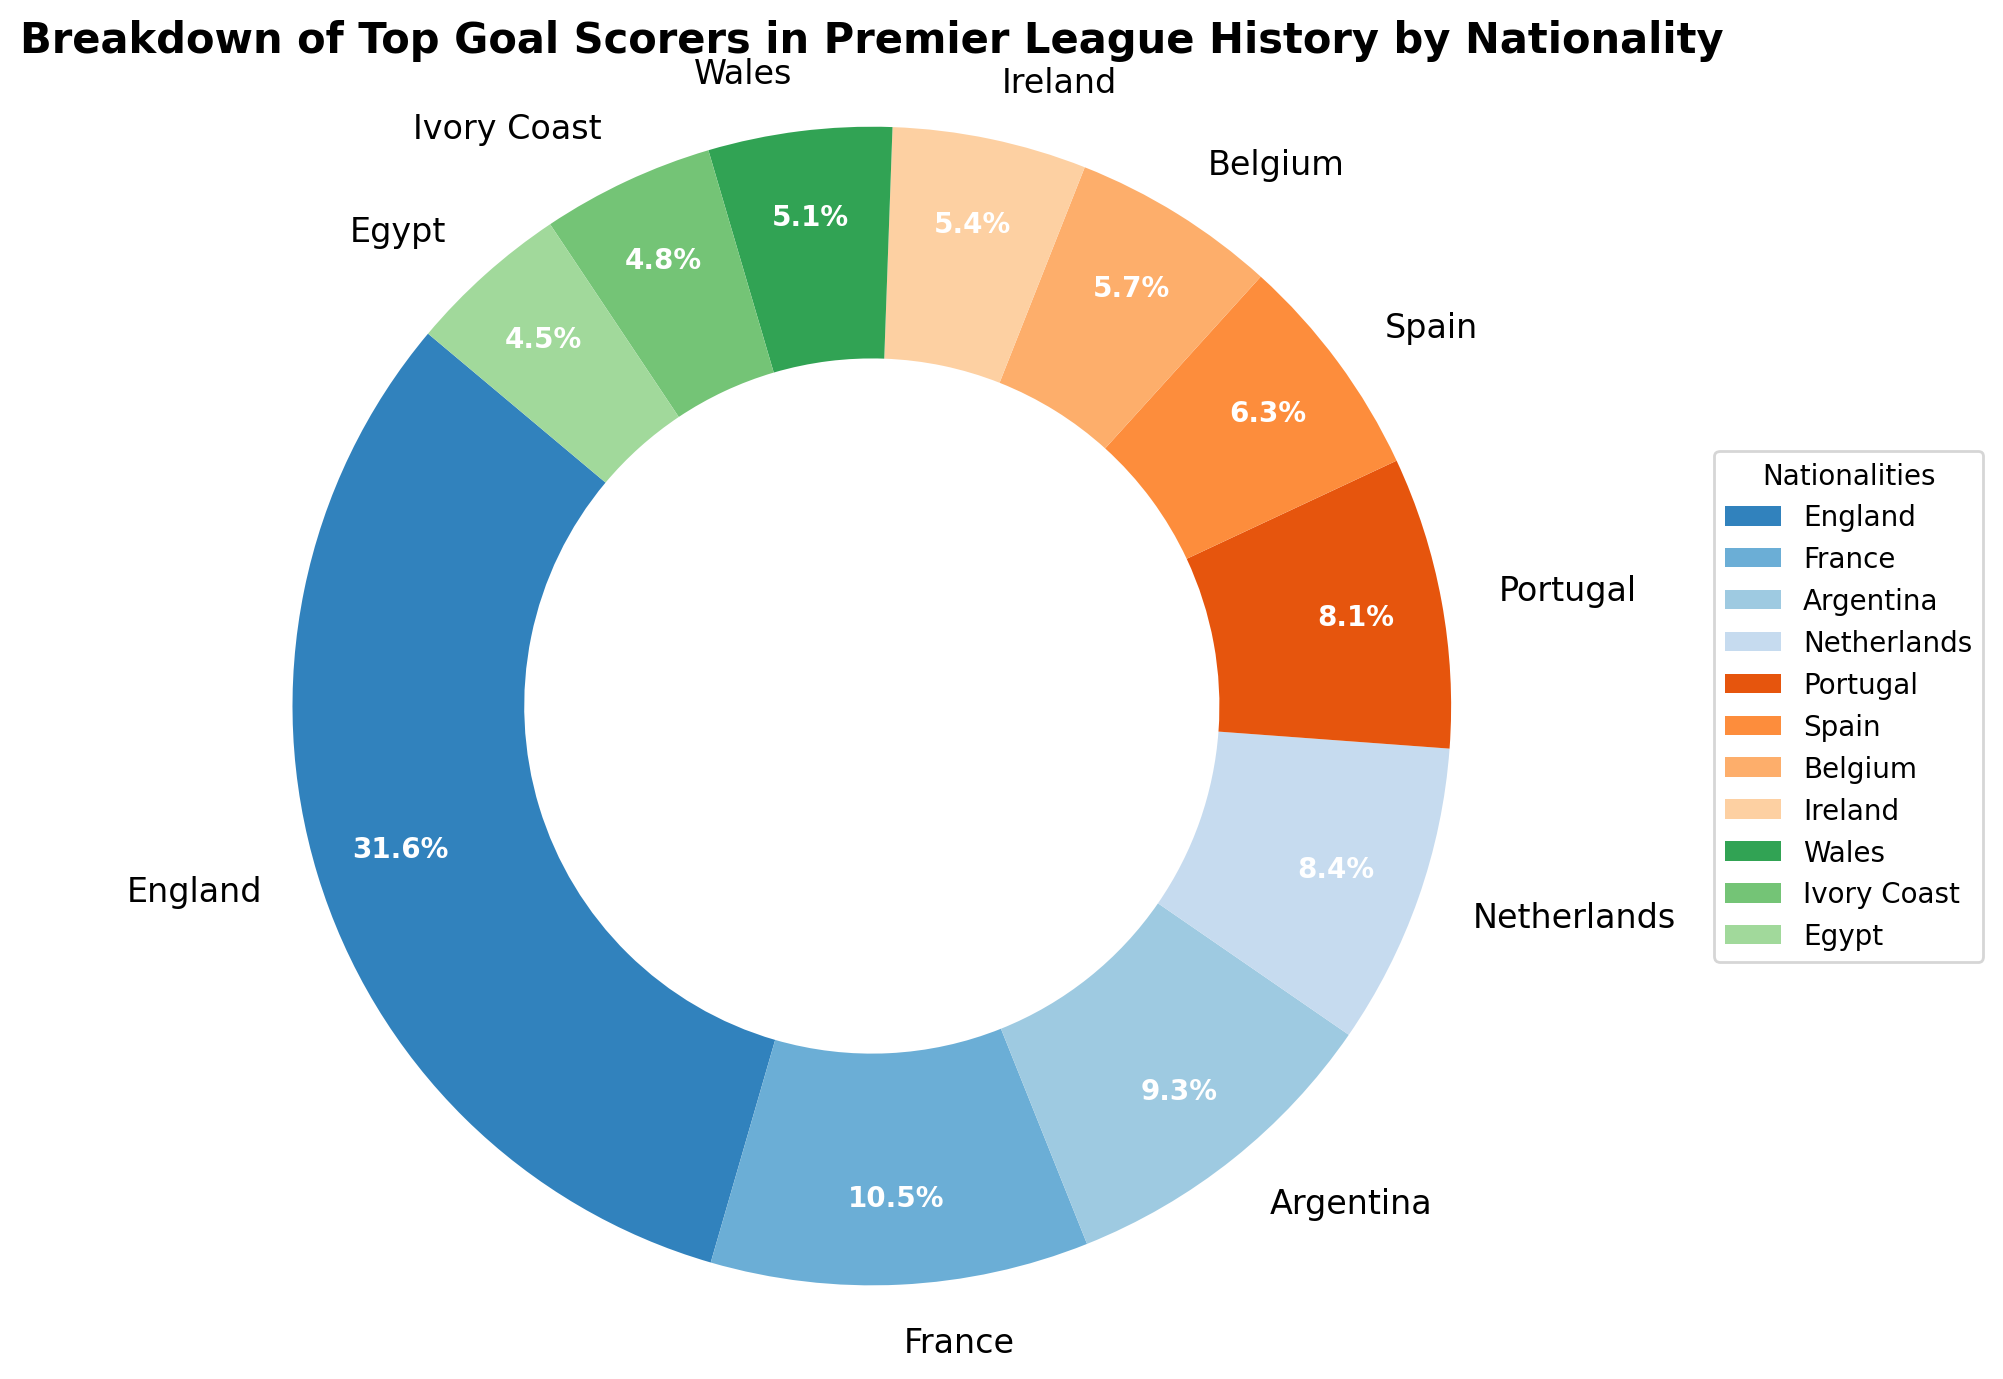Which nationality has the highest number of goals in Premier League history? England has the highest number of goals. The data shows that English players have scored 10,500 goals, which is the largest number of goals among all nationalities presented.
Answer: England What percentage of the total goals were scored by French players? To find the percentage of goals scored by French players, divide the number of goals by French players (3,500) by the total number of goals (34,300). Then, multiply by 100: (3500/34300)*100 ≈ 10.2%. The pie chart shows this exact percentage, confirming the calculation.
Answer: 10.2% How many more goals have Argentine players scored compared to Belgian players? Look at the figure to find the number of goals scored by Argentine (3,100) and Belgian (1,900) players. Subtract Belgian goals from Argentine goals: 3,100 - 1,900 = 1,200 goals.
Answer: 1,200 goals Which two nationalities have the smallest difference in the number of goals scored, and what is that difference? Look at the goals for every pair of nationalities. The smallest difference is between Netherlands (2,800 goals) and Portugal (2,700 goals). The difference is 2,800 - 2,700 = 100 goals.
Answer: Netherlands and Portugal, 100 goals What is the combined percentage of goals by players from Wales and Ireland? Add the goals for Wales (1,700) and Ireland (1,800) to get 3,500 goals. Calculate the combined percentage: (3,500/34,300)*100 ≈ 10.2%. The pie chart verifies this calculation by showing their combined segments.
Answer: 10.2% How does the number of goals by Spanish players compare to the number by Portuguese players? Spanish players have scored 2,100 goals while Portuguese players have scored 2,700 goals. By comparing, we see that Portuguese players have scored 600 more goals than Spanish players.
Answer: Portuguese players scored 600 more goals What proportion of the total goals were scored by players from Ivory Coast? The number of goals scored by Ivory Coast players is 1,600. To find the proportion, divide 1,600 by the total number of goals (34,300). This gives (1600/34300) ≈ 0.0466, or 4.7%.
Answer: 4.7% What is the sum of goals scored by players from the top four nationalities? Look at the goals for the top four nationalities: England (10,500), France (3,500), Argentina (3,100), and Netherlands (2,800). Sum these numbers: 10,500 + 3,500 + 3,100 + 2,800 = 19,900 goals.
Answer: 19,900 goals Which nationality has the smallest segment in the pie chart, and what does this segment represent in terms of goals and percentage? The smallest segment in the pie chart corresponds to Egypt, which has 1,500 goals. Calculating the percentage: (1500/34300)*100 ≈ 4.4%.
Answer: Egypt, 1,500 goals, 4.4% Considering the visual attributes of the pie chart, which color is used to represent English players, and what does that indicate? The pie chart uses one of the prominent colors (usually the first one) to represent English players. They've scored the most goals, and this segment will likely also be the largest in area.
Answer: English players have the largest segment 